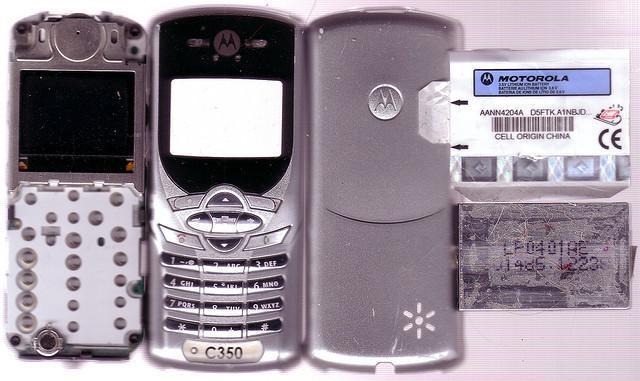How many cell phones are in the photo?
Give a very brief answer. 3. How many people are only seen from the back on the image?
Give a very brief answer. 0. 